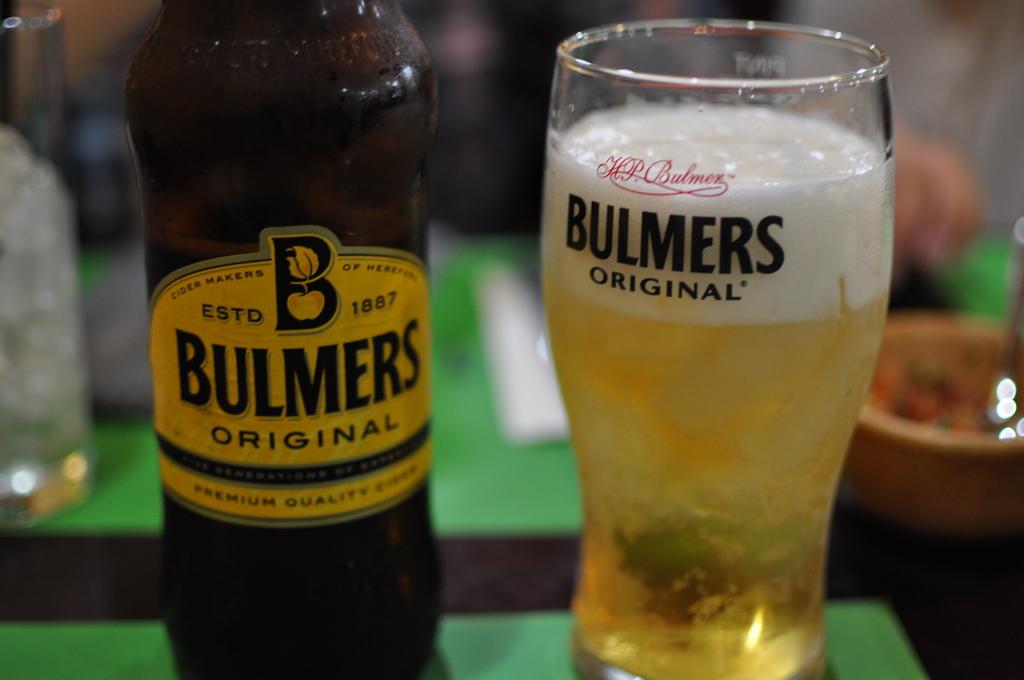What glass is that?
Make the answer very short. Bulmers original. When was this drink established?
Ensure brevity in your answer.  1887. 